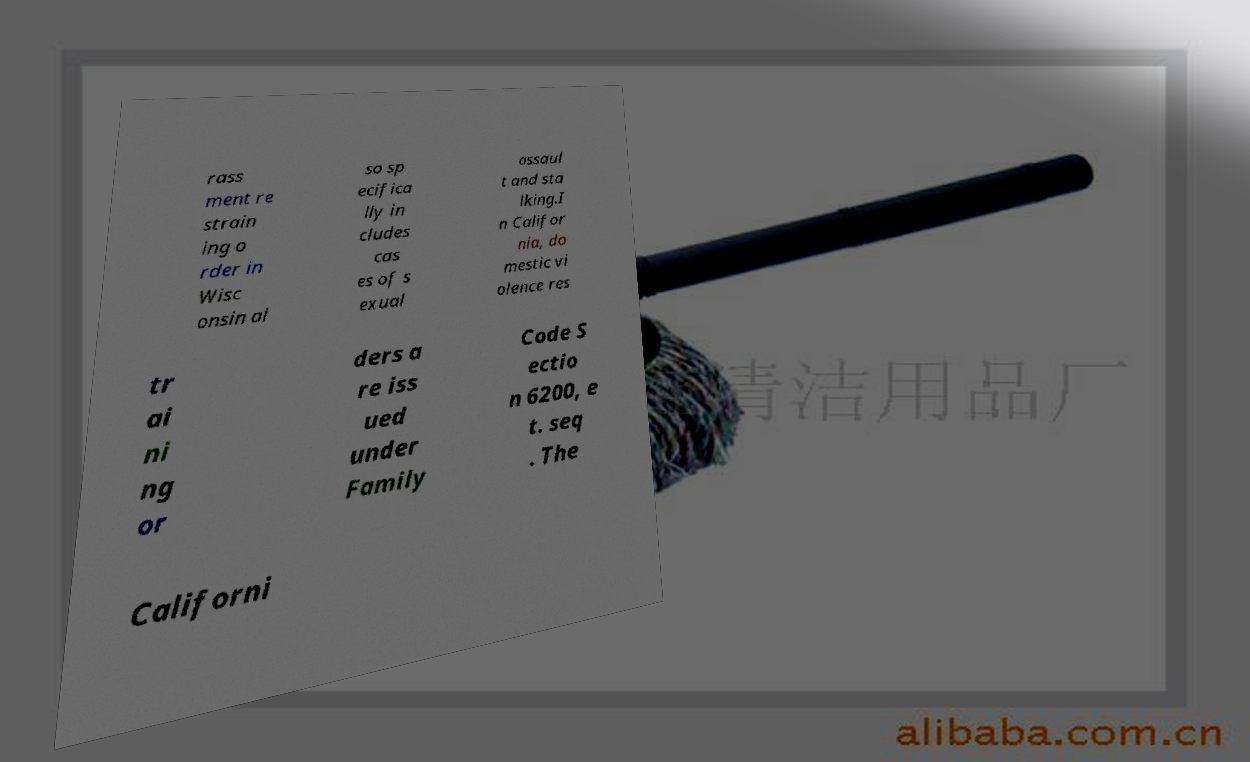Please read and relay the text visible in this image. What does it say? rass ment re strain ing o rder in Wisc onsin al so sp ecifica lly in cludes cas es of s exual assaul t and sta lking.I n Califor nia, do mestic vi olence res tr ai ni ng or ders a re iss ued under Family Code S ectio n 6200, e t. seq . The Californi 